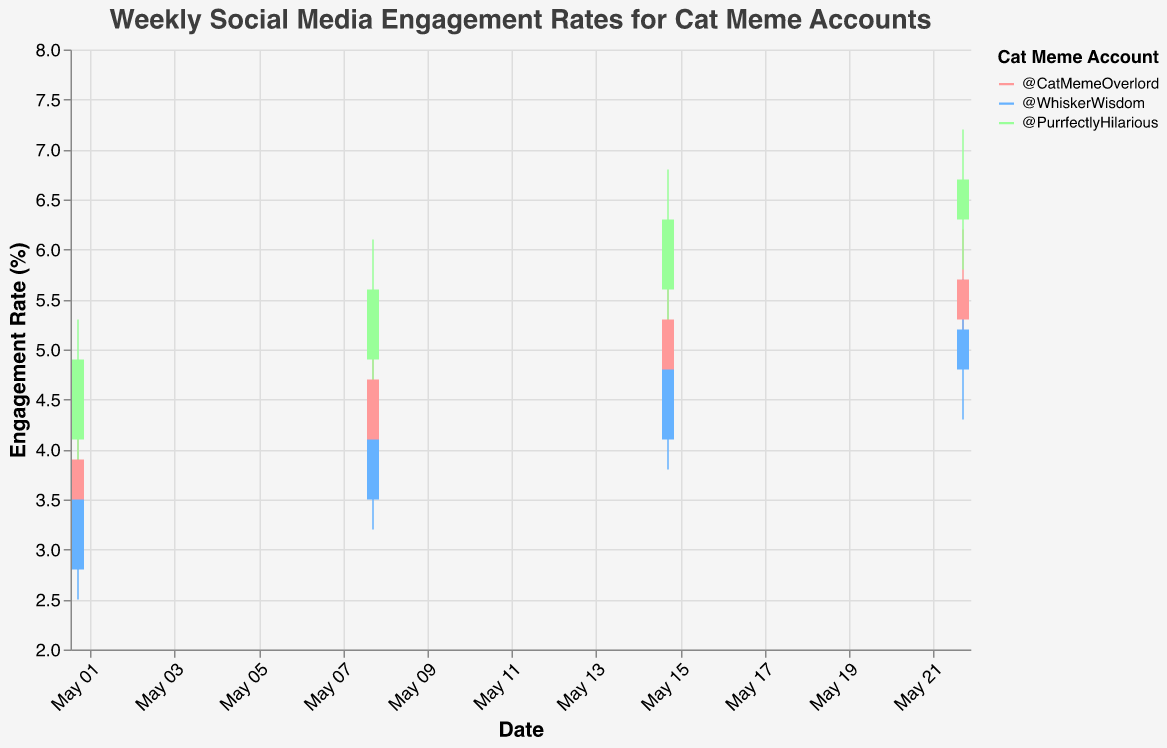what is the title of the figure? The title is displayed at the top of the figure in large text.
Answer: Weekly Social Media Engagement Rates for Cat Meme Accounts How many different accounts are shown in the chart? There are three distinct colors in the legend, each corresponding to a cat meme account.
Answer: 3 Which account had the highest engagement rate during the week of May 22, 2023? Look at the data points for May 22 and compare the 'High' values for each account. @PurrfectlyHilarious has the highest 'High' value of 7.2.
Answer: @PurrfectlyHilarious What were the opening and closing engagement rates for @WhiskerWisdom on May 8, 2023? Refer to the data points for May 8 for @WhiskerWisdom and check the 'Open' and 'Close' values. The values are 3.5 and 4.1, respectively.
Answer: 3.5, 4.1 On which date did @CatMemeOverlord have the highest high engagement rate, and what was the rate? Compare the 'High' values for @CatMemeOverlord across all dates and find the maximum value. The highest 'High' rate is on May 22 with a value of 6.2.
Answer: May 22, 6.2 Which account showed the most consistent increase in engagement rates over the four weeks? @PurrfectlyHilarious consistently increases its 'Close' values every week: 4.9, 5.6, 6.3, and 6.7.
Answer: @PurrfectlyHilarious Compare the engagement rate ranges (High-Low) for @CatMemeOverlord and @WhiskerWisdom on May 15. Calculate the range for both accounts: @CatMemeOverlord (5.8 - 4.2 = 1.6), @WhiskerWisdom (5.2 - 3.8 = 1.4). Thus, @CatMemeOverlord has a slightly larger range.
Answer: @CatMemeOverlord What is the overall trend of engagement rates for @CatMemeOverlord from the beginning to the end of the month? Observe the 'Close' values for @CatMemeOverlord over the four weeks (3.9, 4.7, 5.3, 5.7). The trend is an increase.
Answer: Increasing Calculate the average high engagement rate for @PurrfectlyHilarious over the four weeks. Sum the 'High' values for @PurrfectlyHilarious (5.3 + 6.1 + 6.8 + 7.2) = 25.4 and divide by 4.
Answer: 6.35 Which account had the lowest closing engagement rate on May 1 and what was the rate? Compare 'Close' values for May 1 among the accounts. @WhiskerWisdom had the lowest with 3.5.
Answer: @WhiskerWisdom, 3.5 